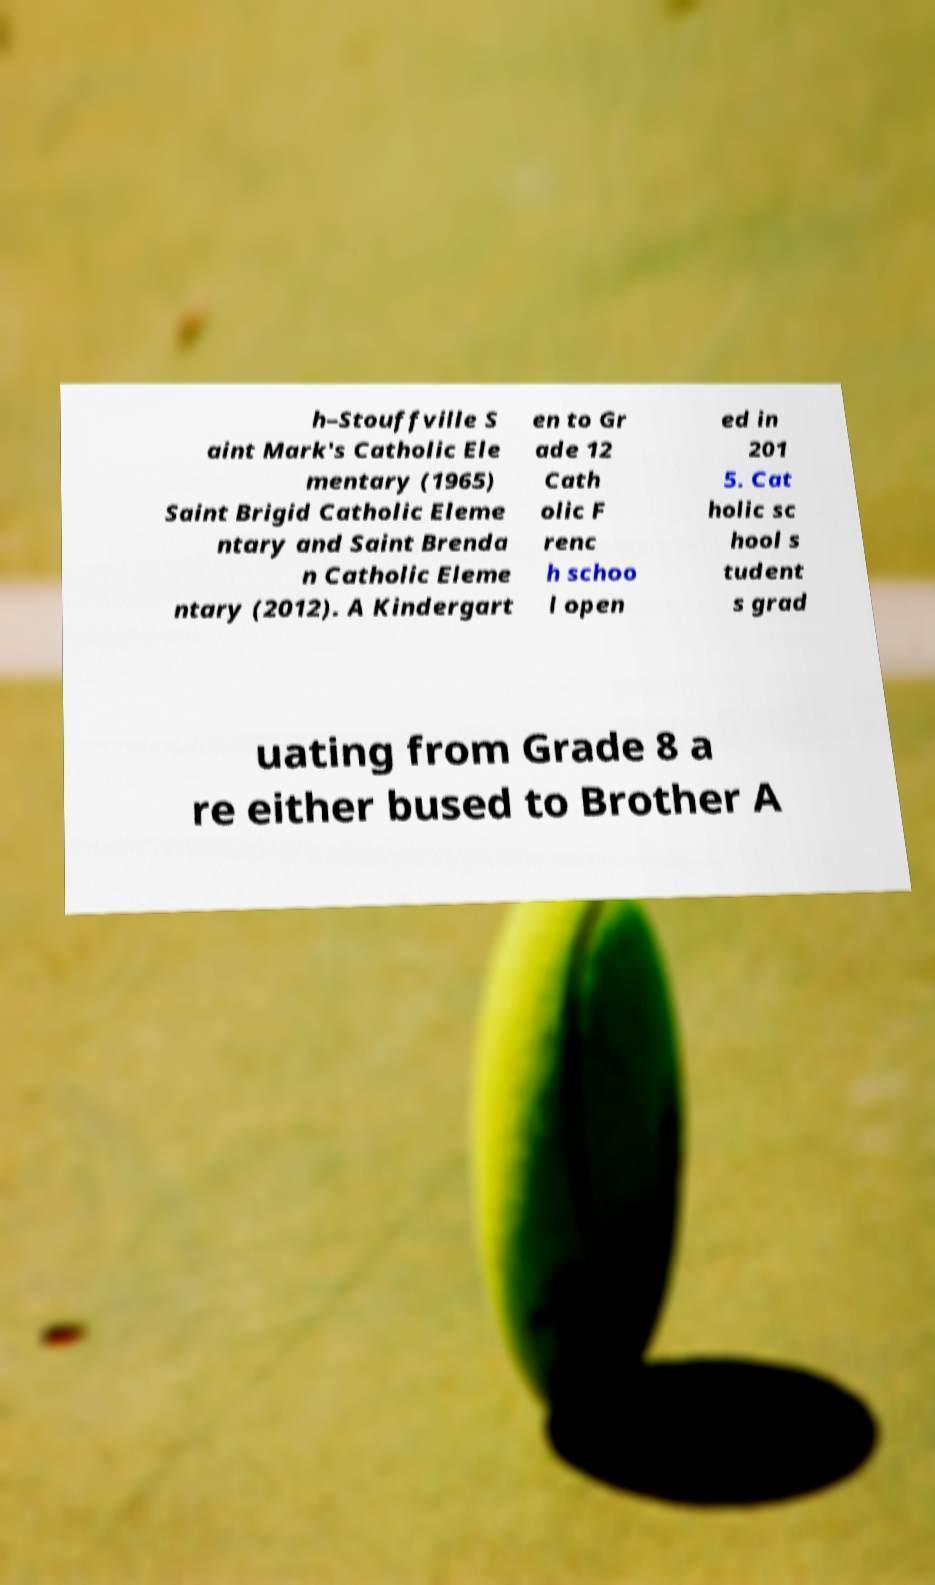For documentation purposes, I need the text within this image transcribed. Could you provide that? h–Stouffville S aint Mark's Catholic Ele mentary (1965) Saint Brigid Catholic Eleme ntary and Saint Brenda n Catholic Eleme ntary (2012). A Kindergart en to Gr ade 12 Cath olic F renc h schoo l open ed in 201 5. Cat holic sc hool s tudent s grad uating from Grade 8 a re either bused to Brother A 